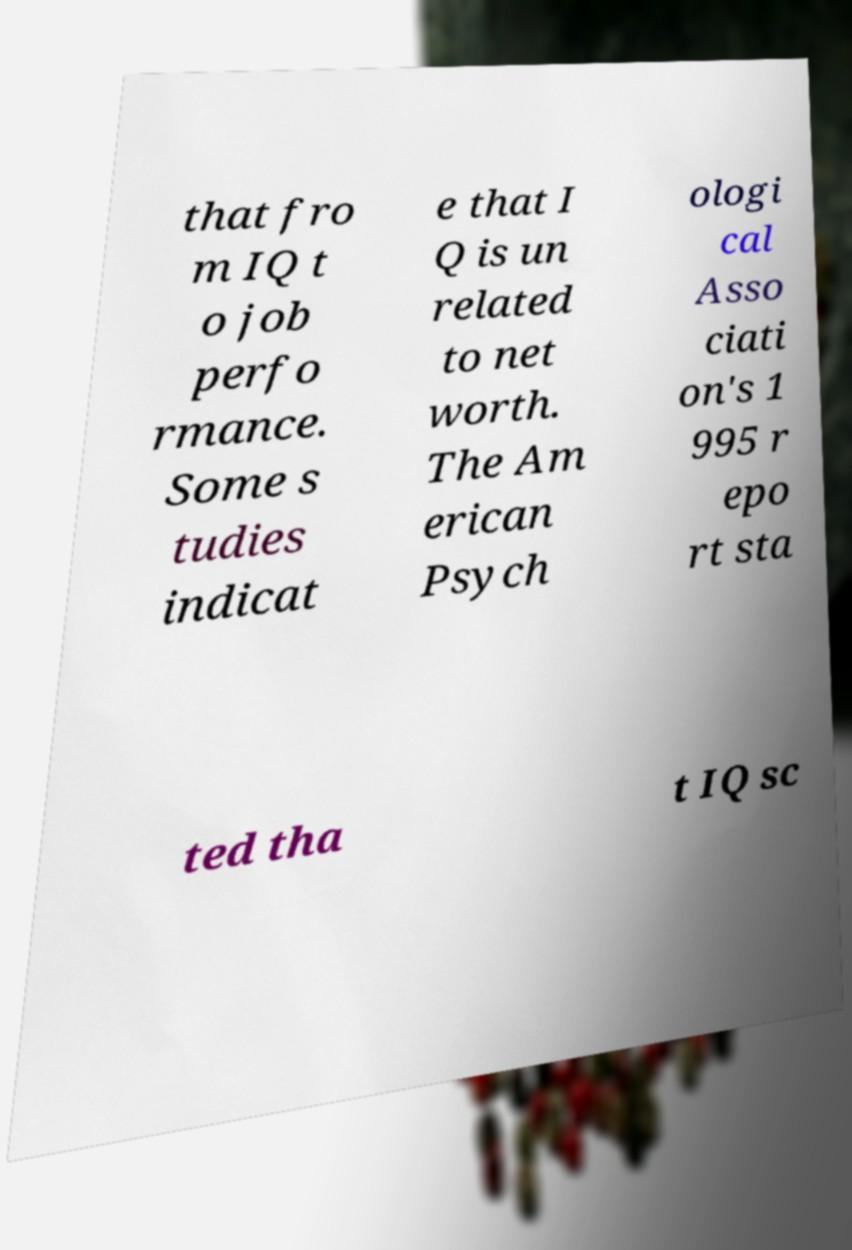What messages or text are displayed in this image? I need them in a readable, typed format. that fro m IQ t o job perfo rmance. Some s tudies indicat e that I Q is un related to net worth. The Am erican Psych ologi cal Asso ciati on's 1 995 r epo rt sta ted tha t IQ sc 